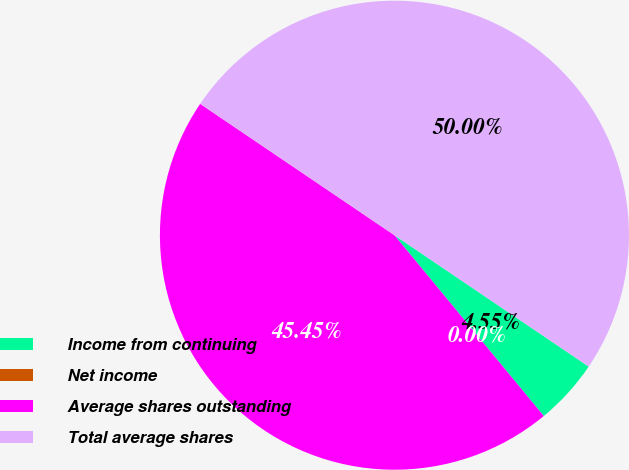Convert chart to OTSL. <chart><loc_0><loc_0><loc_500><loc_500><pie_chart><fcel>Income from continuing<fcel>Net income<fcel>Average shares outstanding<fcel>Total average shares<nl><fcel>4.55%<fcel>0.0%<fcel>45.45%<fcel>50.0%<nl></chart> 